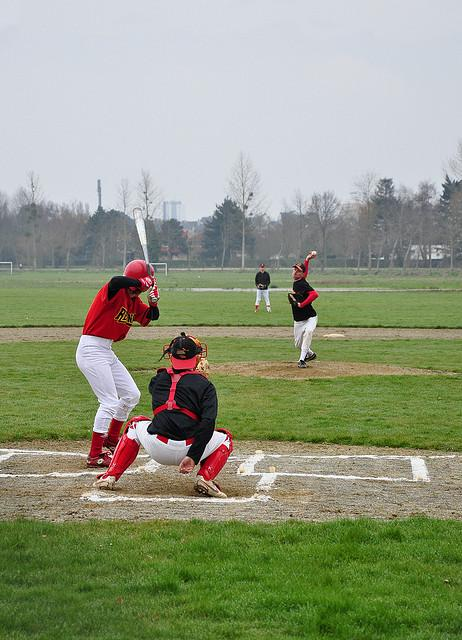What is the opposite form of this pitch? underhand 